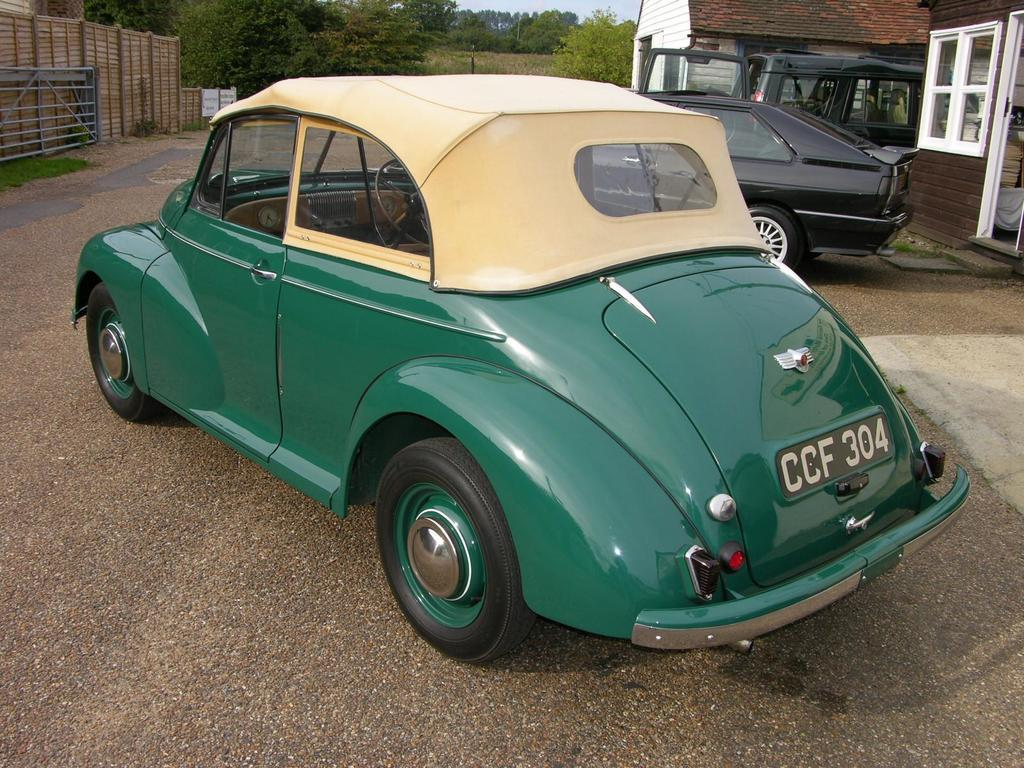What types of objects are on the ground in the image? There are vehicles on the ground in the image. What structure can be seen in the image? There is a gate in the image. What architectural feature is present in the image? There is a wall in the image. What type of buildings can be seen in the image? There are houses with windows in the image. What can be seen in the background of the image? There are trees and the sky visible in the background of the image. Can you tell me where the receipt is located in the image? There is no receipt present in the image. How many lizards can be seen climbing on the houses in the image? There are no lizards present in the image. 